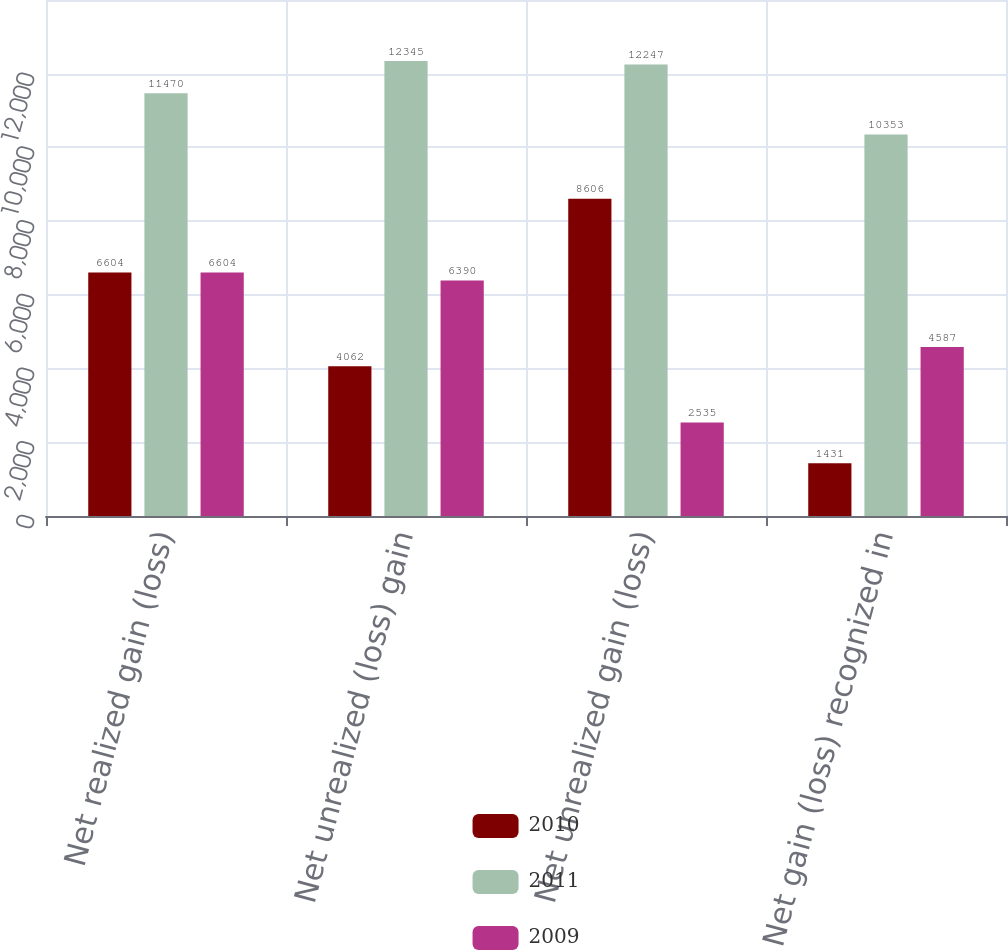Convert chart. <chart><loc_0><loc_0><loc_500><loc_500><stacked_bar_chart><ecel><fcel>Net realized gain (loss)<fcel>Net unrealized (loss) gain<fcel>Net unrealized gain (loss)<fcel>Net gain (loss) recognized in<nl><fcel>2010<fcel>6604<fcel>4062<fcel>8606<fcel>1431<nl><fcel>2011<fcel>11470<fcel>12345<fcel>12247<fcel>10353<nl><fcel>2009<fcel>6604<fcel>6390<fcel>2535<fcel>4587<nl></chart> 